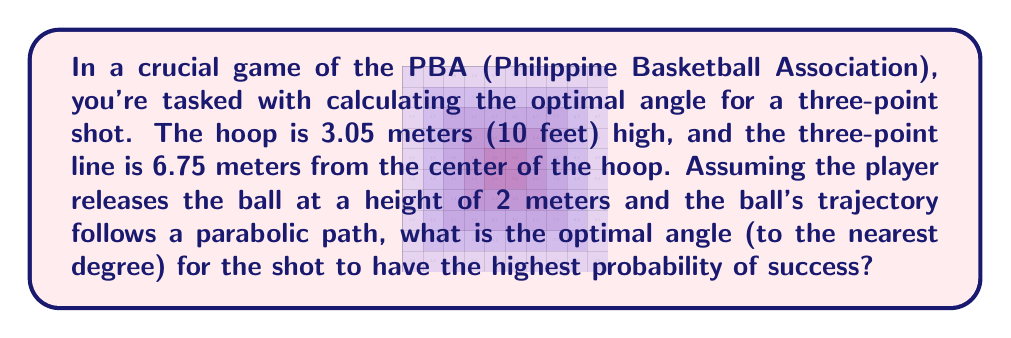Solve this math problem. Let's approach this step-by-step:

1) First, we need to set up our coordinate system. Let's place the origin (0,0) at the point where the player releases the ball.

2) The hoop's position can be described as (6.75, 1.05), since it's 6.75 meters away horizontally and 1.05 meters higher than the release point (3.05m - 2m = 1.05m).

3) The trajectory of the ball can be described by a quadratic function:

   $$y = ax^2 + bx$$

   Where $a < 0$ (because the parabola opens downward) and $b > 0$ (because the ball initially goes up).

4) The optimal angle is the one that gives the ball the most room for error when it reaches the hoop. This occurs when the ball reaches the highest point of its arc directly above the hoop.

5) For this to happen, the vertex of the parabola should be at x = 6.75/2 = 3.375 meters.

6) The formula for the x-coordinate of the vertex of a parabola is $x = -b/(2a)$. So:

   $$3.375 = -b/(2a)$$

7) We also know that the parabola passes through (0,0) and (6.75, 1.05). Substituting these into our quadratic equation:

   $$0 = a(0)^2 + b(0)$$
   $$1.05 = a(6.75)^2 + b(6.75)$$

8) From step 6, we can say $b = -6.75a$. Substituting this into the equation from step 7:

   $$1.05 = a(6.75)^2 - 6.75a(6.75)$$
   $$1.05 = 45.5625a - 45.5625a = 0$$

   This doesn't give us useful information, so we need another approach.

9) The slope of the tangent line at the release point (0,0) is equal to $b$, and this slope is also equal to $\tan(\theta)$, where $\theta$ is the release angle.

10) From step 6, we know that $b = -6.75a$. Substituting this into the equation from step 7:

    $$1.05 = a(6.75)^2 - 6.75a(6.75)$$
    $$1.05 = 45.5625a - 45.5625a$$
    $$1.05 = 0$$

    This is always true, so we need one more condition.

11) The vertex of the parabola should be at (3.375, h), where h is the maximum height. We can find h using the original quadratic equation:

    $$h = a(3.375)^2 + b(3.375)$$

12) Substituting $b = -6.75a$:

    $$h = a(3.375)^2 - 6.75a(3.375)$$
    $$h = 11.390625a - 22.78125a$$
    $$h = -11.390625a$$

13) Now, we can use the fact that the parabola passes through (6.75, 1.05):

    $$1.05 = a(6.75)^2 + b(6.75)$$
    $$1.05 = 45.5625a - 6.75^2a$$
    $$1.05 = -45.5625a$$
    $$a = -0.02305$$

14) Now we can find $b$:

    $$b = -6.75a = -6.75(-0.02305) = 0.1556$$

15) The optimal angle is therefore:

    $$\theta = \arctan(b) = \arctan(0.1556) \approx 8.84°$$

Rounding to the nearest degree, we get 9°.
Answer: 9° 